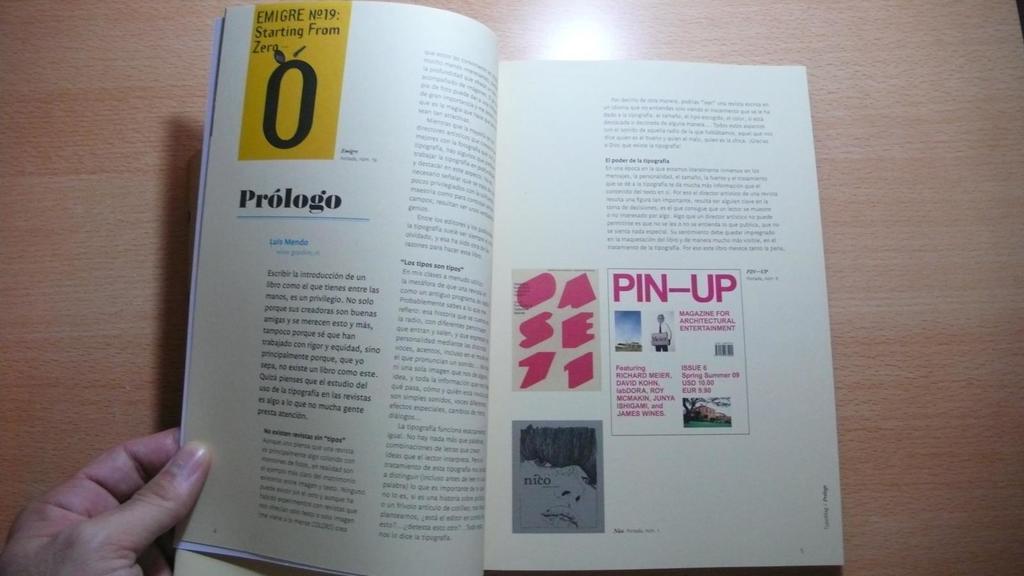In the yellow box, what number is it starting from?
Keep it short and to the point. 0. 